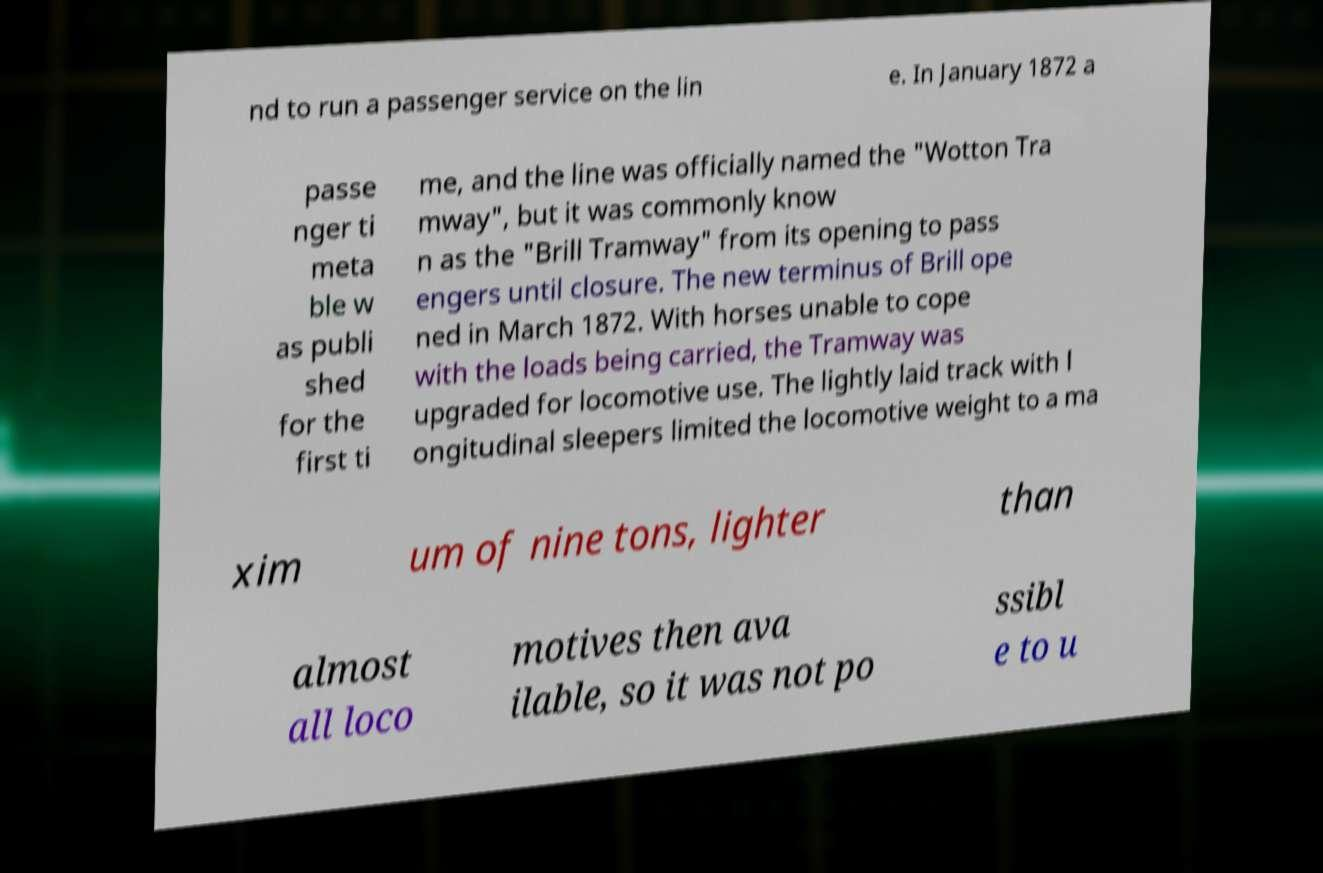There's text embedded in this image that I need extracted. Can you transcribe it verbatim? nd to run a passenger service on the lin e. In January 1872 a passe nger ti meta ble w as publi shed for the first ti me, and the line was officially named the "Wotton Tra mway", but it was commonly know n as the "Brill Tramway" from its opening to pass engers until closure. The new terminus of Brill ope ned in March 1872. With horses unable to cope with the loads being carried, the Tramway was upgraded for locomotive use. The lightly laid track with l ongitudinal sleepers limited the locomotive weight to a ma xim um of nine tons, lighter than almost all loco motives then ava ilable, so it was not po ssibl e to u 